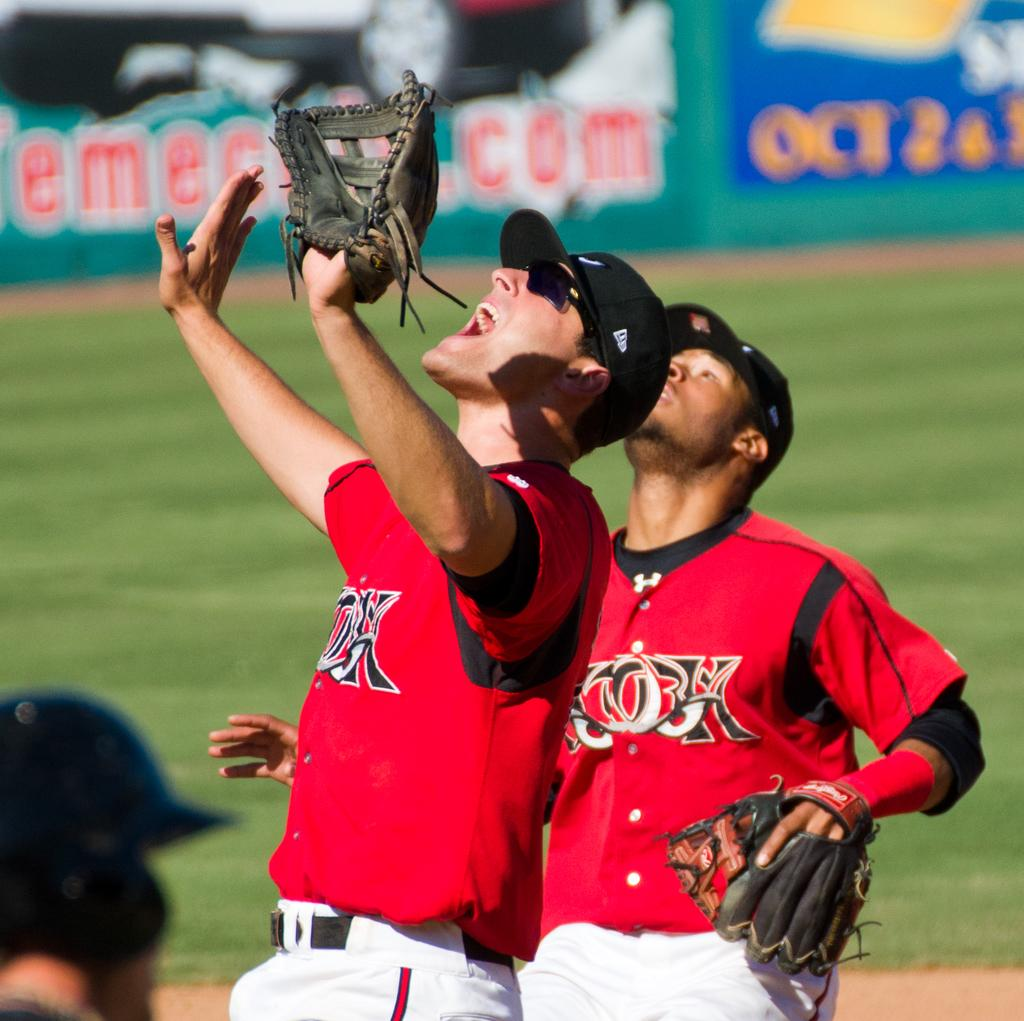<image>
Offer a succinct explanation of the picture presented. the sign at the back of a baseball field says Oct 2 